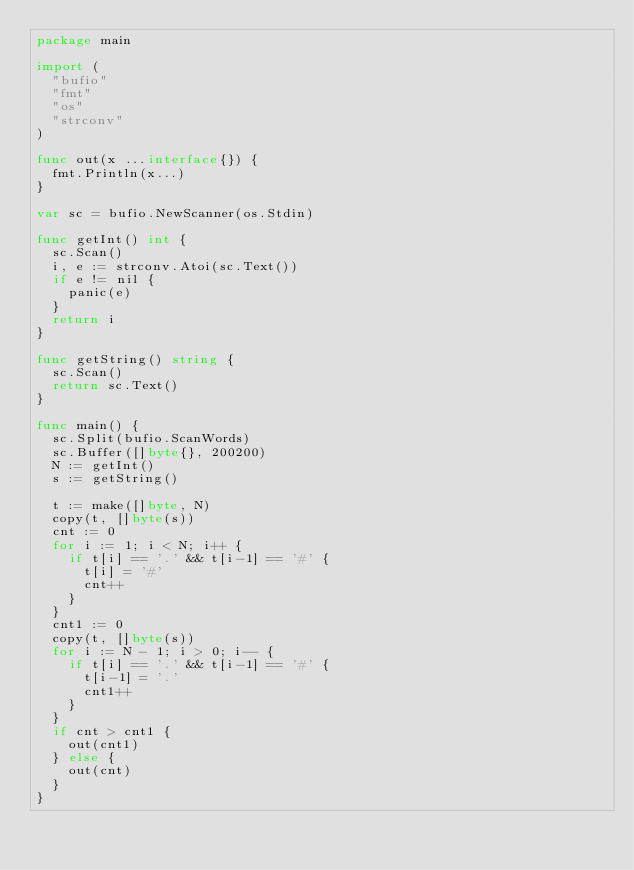<code> <loc_0><loc_0><loc_500><loc_500><_Go_>package main

import (
	"bufio"
	"fmt"
	"os"
	"strconv"
)

func out(x ...interface{}) {
	fmt.Println(x...)
}

var sc = bufio.NewScanner(os.Stdin)

func getInt() int {
	sc.Scan()
	i, e := strconv.Atoi(sc.Text())
	if e != nil {
		panic(e)
	}
	return i
}

func getString() string {
	sc.Scan()
	return sc.Text()
}

func main() {
	sc.Split(bufio.ScanWords)
	sc.Buffer([]byte{}, 200200)
	N := getInt()
	s := getString()

	t := make([]byte, N)
	copy(t, []byte(s))
	cnt := 0
	for i := 1; i < N; i++ {
		if t[i] == '.' && t[i-1] == '#' {
			t[i] = '#'
			cnt++
		}
	}
	cnt1 := 0
	copy(t, []byte(s))
	for i := N - 1; i > 0; i-- {
		if t[i] == '.' && t[i-1] == '#' {
			t[i-1] = '.'
			cnt1++
		}
	}
	if cnt > cnt1 {
		out(cnt1)
	} else {
		out(cnt)
	}
}
</code> 